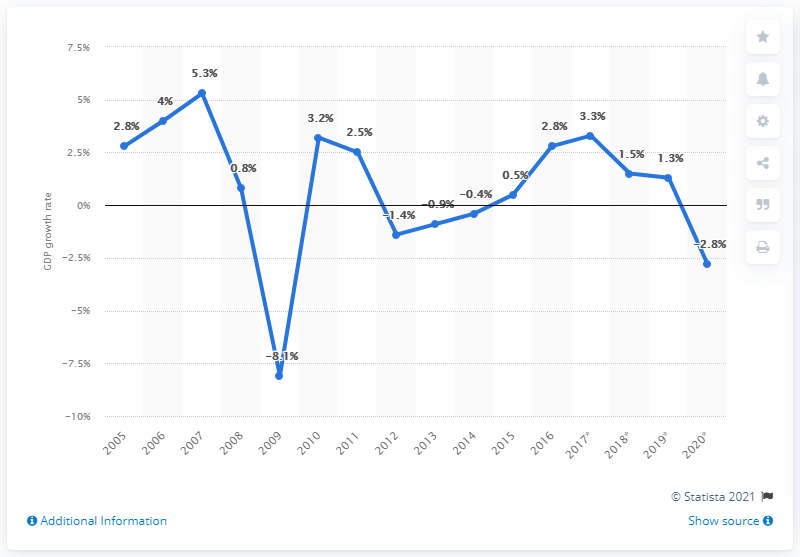Identify some key points in this picture. According to the provided information, Finland's GDP growth rate did not reach pre-crisis levels until 2009. The Gross Domestic Product (GDP) growth rate in 2020 was 2.8%. 